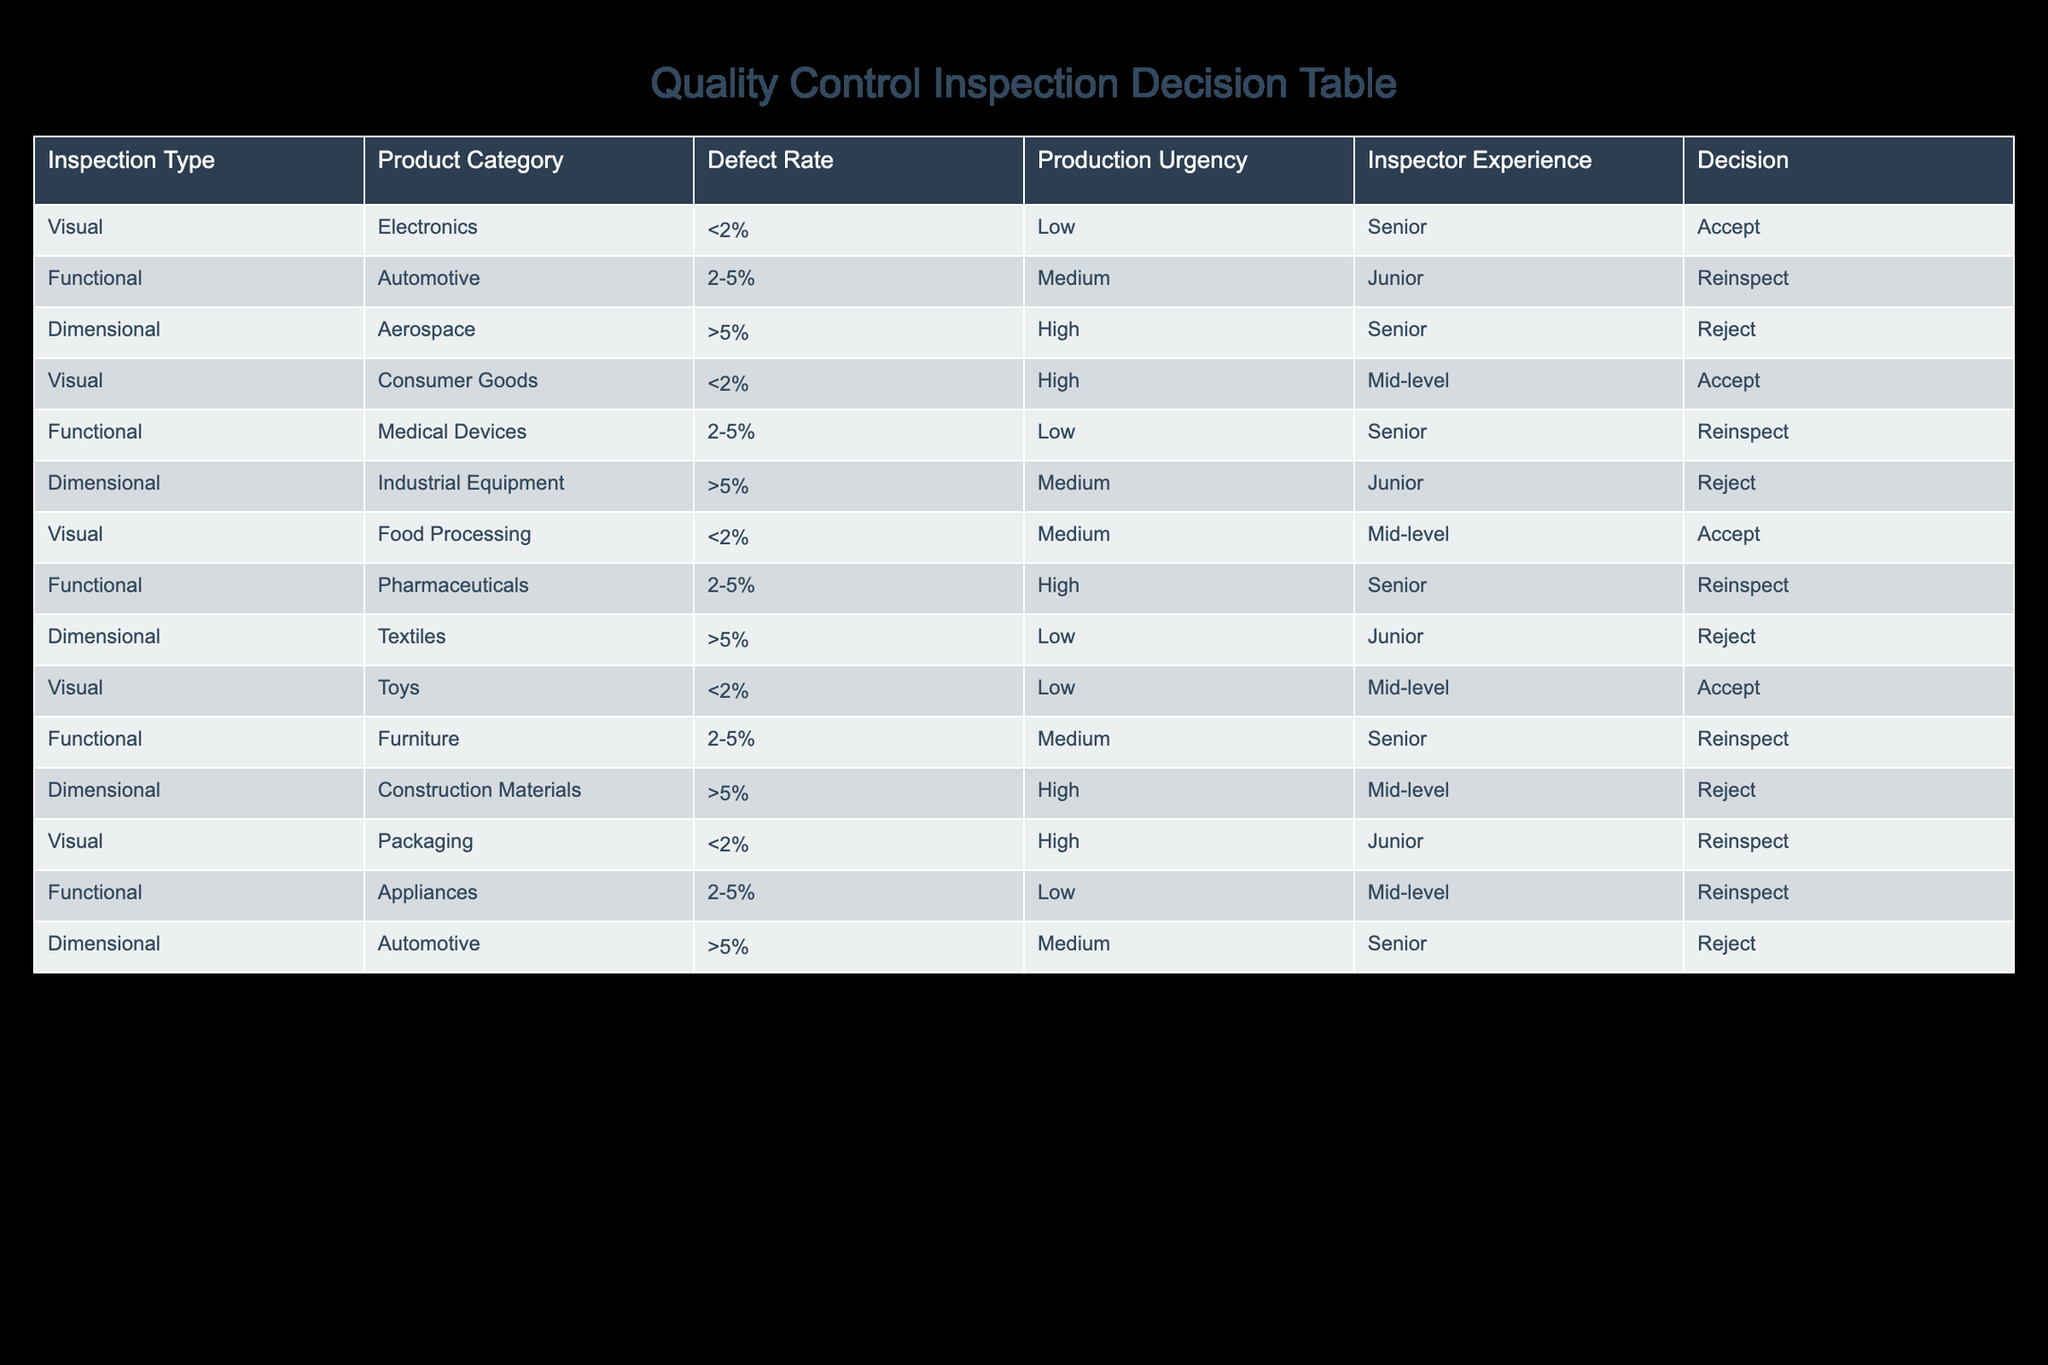What is the decision for visual inspection of electronics with a defect rate of less than 2%? The table shows that for visual inspection of electronics, the defect rate is less than 2% and the decision is to accept.
Answer: Accept What is the production urgency for dimensional inspection of aerospace products? According to the table, the production urgency for dimensional inspection of aerospace products is categorized as high.
Answer: High How many inspection types result in an accept decision overall? The table indicates that there are 4 types of inspection that result in an accept decision: visual inspections of electronics, consumer goods, food processing, and toys.
Answer: 4 Is the decision for dimensional inspection of industrial equipment to accept? Looking at the table, the decision for dimensional inspection of industrial equipment is to reject, as the defect rate is greater than 5%.
Answer: No What is the average defect rate across all categories for inspections leading to a reinspect decision? The decisions for reinspect are for functional inspections in automotive, medical devices, pharmaceuticals, furniture, and appliances. Their defect rates are 2-5%. We can treat this as a range from 2% to 5%. The average of 2% and 5% is 3.5%.
Answer: 3.5% Which inspection type has the highest experience requirement resulting in a reject decision? The table shows that both dimensional inspection of aerospace and construction materials lead to a reject decision, but the dimensional inspection of aerospace has a senior inspector, which is the highest experience level required in all reject decisions.
Answer: Dimensional, Aerospace How does the decision differ between visual inspections with low versus high urgency? Visual inspections with low urgency (like electronics, toys) typically lead to accept decisions, while with high urgency (like consumer goods, packaging) some lead to reinspect decisions. This showcases that high urgency may increase scrutiny regardless of defect rate.
Answer: They often differ in accept and reinspect Do junior inspectors only have tasks that involve rejection? The table indicates that junior inspectors perform some tasks that involve rejection (like dimensional inspections of industrial equipment and textiles), but they also have reinspect tasks (like packaging). Therefore, they do not exclusively have rejection tasks.
Answer: No 